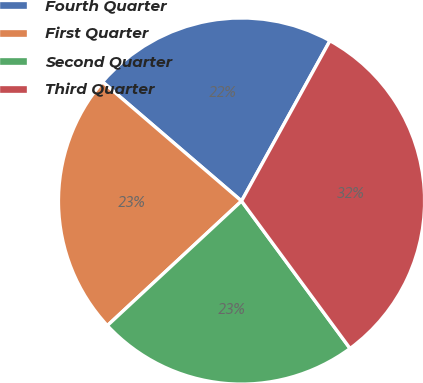<chart> <loc_0><loc_0><loc_500><loc_500><pie_chart><fcel>Fourth Quarter<fcel>First Quarter<fcel>Second Quarter<fcel>Third Quarter<nl><fcel>21.74%<fcel>23.19%<fcel>23.19%<fcel>31.88%<nl></chart> 